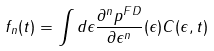Convert formula to latex. <formula><loc_0><loc_0><loc_500><loc_500>f _ { n } ( t ) = \int d \epsilon \frac { \partial ^ { n } p ^ { F D } } { \partial \epsilon ^ { n } } ( \epsilon ) C ( \epsilon , t )</formula> 